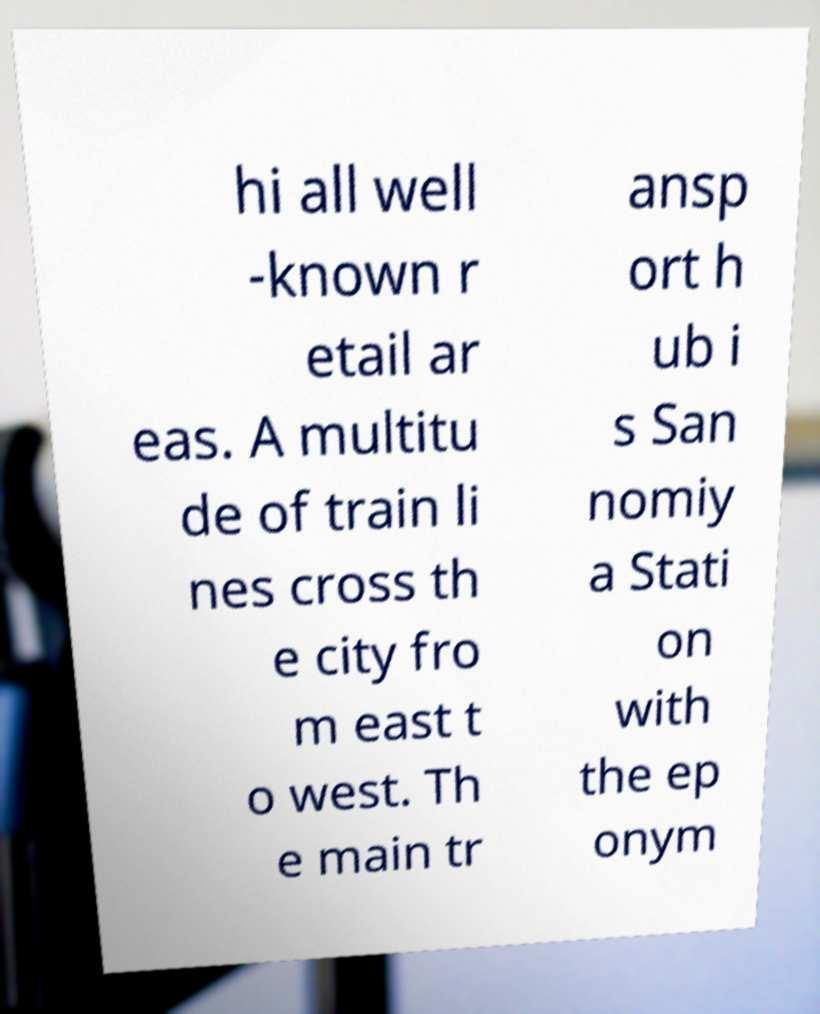What messages or text are displayed in this image? I need them in a readable, typed format. hi all well -known r etail ar eas. A multitu de of train li nes cross th e city fro m east t o west. Th e main tr ansp ort h ub i s San nomiy a Stati on with the ep onym 